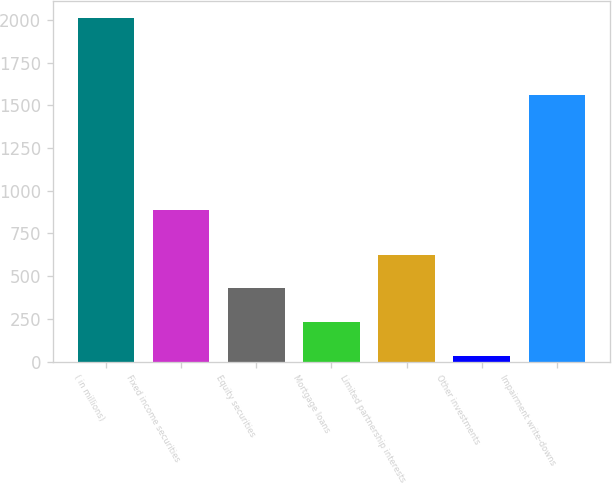<chart> <loc_0><loc_0><loc_500><loc_500><bar_chart><fcel>( in millions)<fcel>Fixed income securities<fcel>Equity securities<fcel>Mortgage loans<fcel>Limited partnership interests<fcel>Other investments<fcel>Impairment write-downs<nl><fcel>2009<fcel>886<fcel>429<fcel>231.5<fcel>626.5<fcel>34<fcel>1562<nl></chart> 